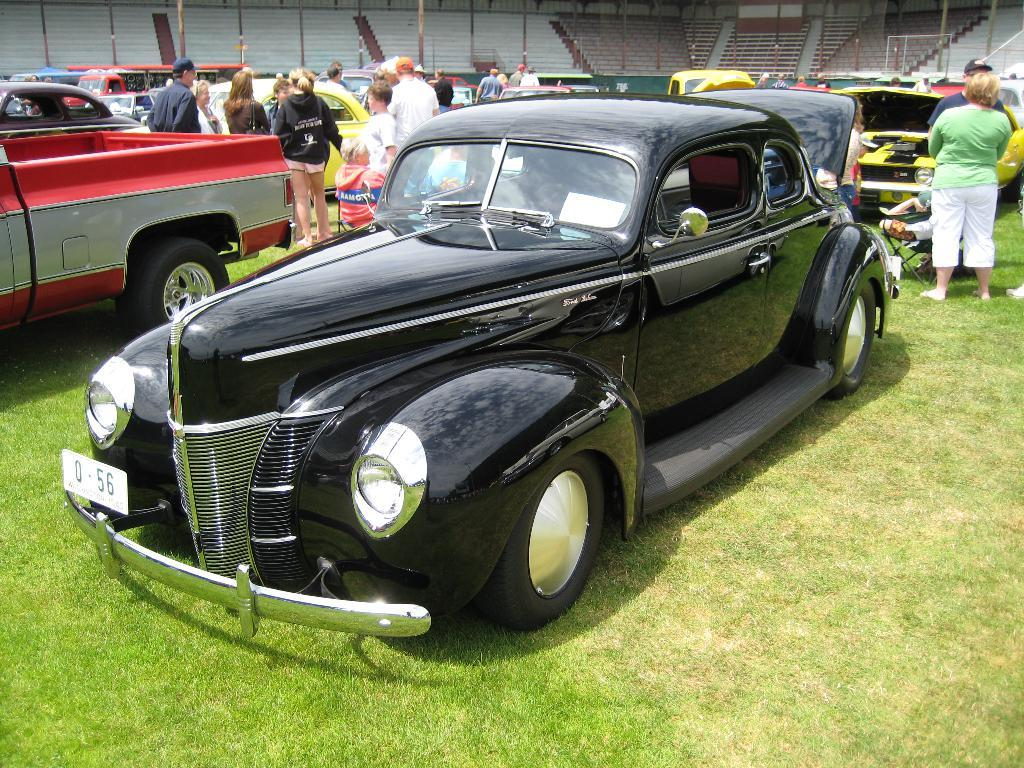How many people are present in the image? There are many people in the image. What can be seen in terms of transportation in the image? There are vehicles with different colors in the image. Where are the vehicles and people located in the image? The vehicles and people are on the ground. What architectural feature can be seen in the background of the image? There are stairs visible in the background of the image. What type of food is being served by the porter in the image? There is no porter or food present in the image. 